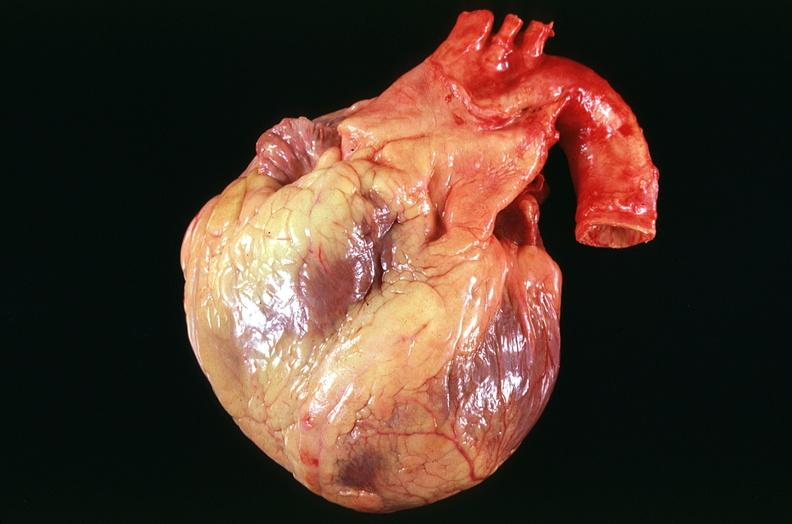s intraductal papillomatosis present?
Answer the question using a single word or phrase. No 